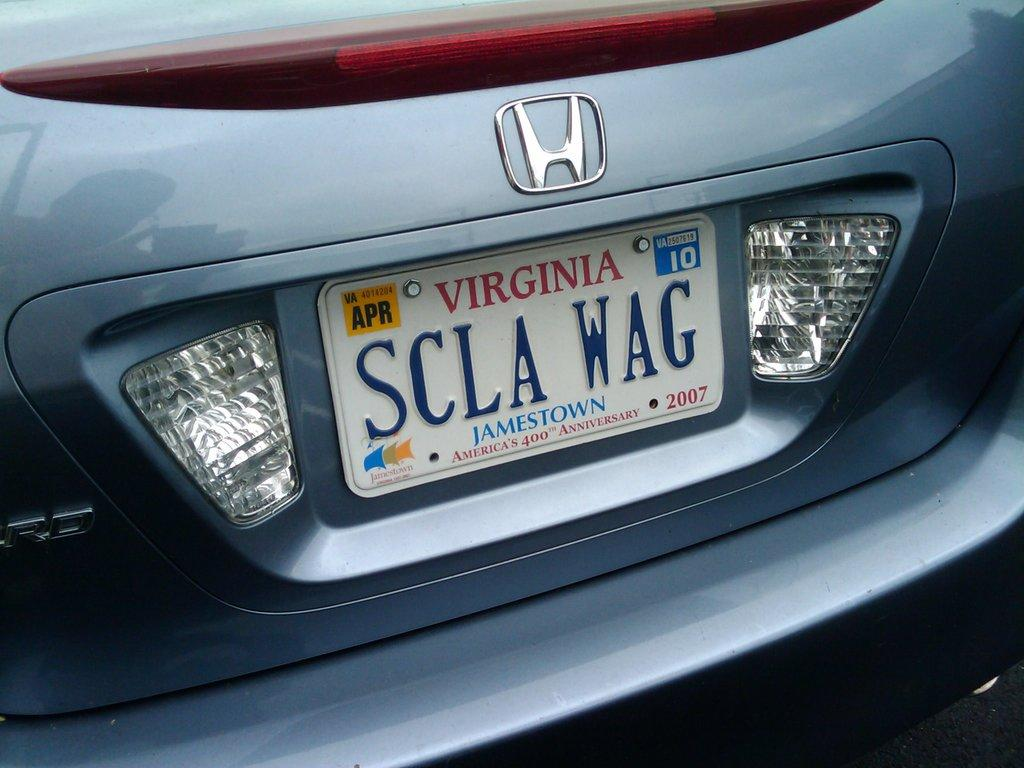<image>
Share a concise interpretation of the image provided. A personalized license plate makes a play on words displaying "SCLA WAG". 